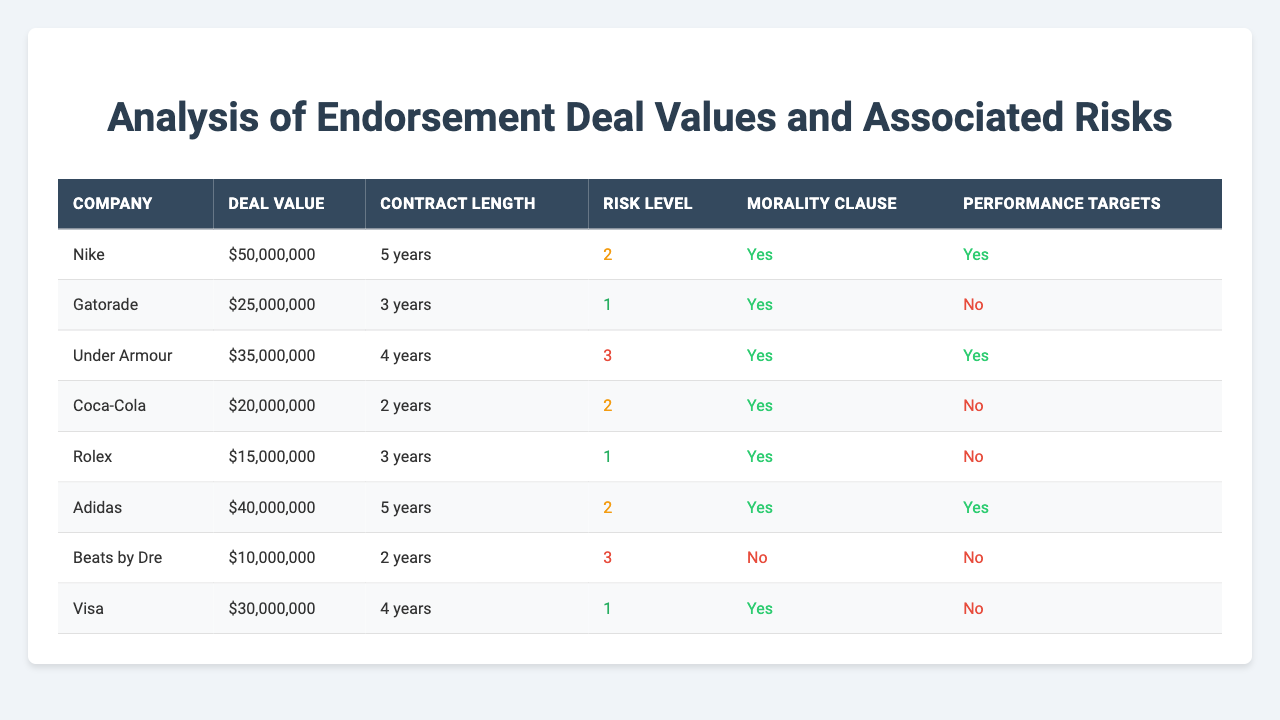What is the deal value of Nike's endorsement? From the table, we can directly see the value listed under Nike's endorsement, which is 50,000,000.
Answer: 50,000,000 Which company has the highest deal value? By comparing the deal values listed in the table, Nike has the highest deal value at 50,000,000.
Answer: Nike How many years is the contract for Under Armour? The contract length for Under Armour is explicitly listed in the table as 4 years.
Answer: 4 years How many companies have a morality clause included in their contract? The morality clause is indicated for each company in the table. Counting the 'Yes' values, we find 7 companies have a morality clause.
Answer: 7 What is the risk level of the endorsement deal with Beats by Dre? The risk level for Beats by Dre is displayed in the table as a risk level of 3.
Answer: 3 What is the total deal value of all the endorsements listed in the table? To find the total, we add all the deal values: 50,000,000 + 25,000,000 + 35,000,000 + 20,000,000 + 15,000,000 + 40,000,000 + 10,000,000 + 30,000,000, resulting in 225,000,000.
Answer: 225,000,000 Which endorsement has performance targets included and a risk level of 2? By examining the table, Adidas has performance targets and a risk level of 2.
Answer: Adidas What is the average contract length of the endorsements? To find the average, we sum the contract lengths (5 + 3 + 4 + 2 + 3 + 5 + 2 + 4 = 28) and divide by the number of endorsements (8), resulting in an average contract length of 3.5 years.
Answer: 3.5 years Is there a company that has both a morality clause and no performance targets? Reviewing the table, Coca-Cola and Rolex have a morality clause but do not have performance targets.
Answer: Yes Which company has the lowest deal value? Looking at the deal values, Beats by Dre has the lowest at 10,000,000.
Answer: Beats by Dre What is the total risk level of all endorsements that have performance targets? The endorsements with performance targets are Nike (2), Under Armour (3), Adidas (2). Summing these values gives us 2 + 3 + 2 = 7.
Answer: 7 